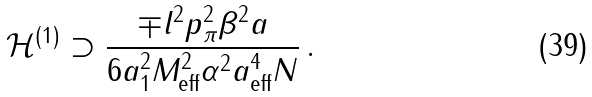<formula> <loc_0><loc_0><loc_500><loc_500>\mathcal { H } ^ { ( 1 ) } \supset \frac { \mp l ^ { 2 } p _ { \pi } ^ { 2 } \beta ^ { 2 } a } { 6 a _ { 1 } ^ { 2 } M _ { \text {eff} } ^ { 2 } \alpha ^ { 2 } a _ { \text {eff} } ^ { 4 } N } \, .</formula> 